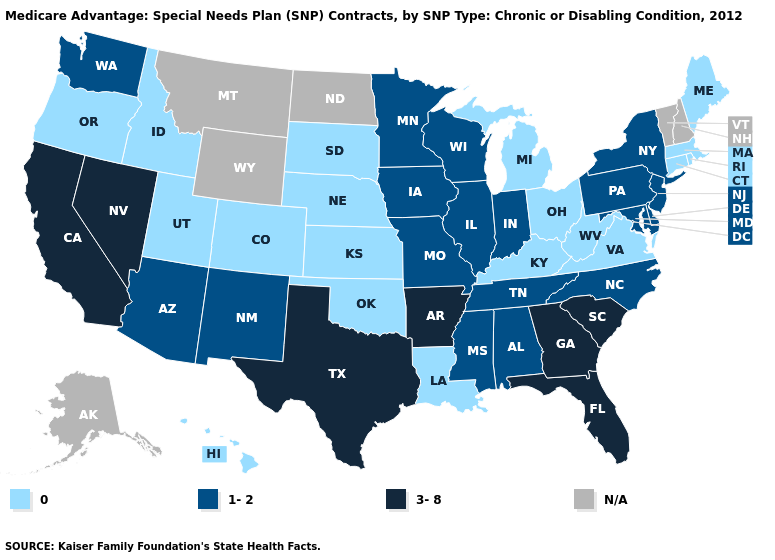Name the states that have a value in the range N/A?
Write a very short answer. Alaska, Montana, North Dakota, New Hampshire, Vermont, Wyoming. Name the states that have a value in the range 3-8?
Answer briefly. Arkansas, California, Florida, Georgia, Nevada, South Carolina, Texas. What is the value of Oregon?
Give a very brief answer. 0. Among the states that border Minnesota , which have the highest value?
Quick response, please. Iowa, Wisconsin. Among the states that border California , which have the lowest value?
Keep it brief. Oregon. Name the states that have a value in the range 1-2?
Write a very short answer. Alabama, Arizona, Delaware, Iowa, Illinois, Indiana, Maryland, Minnesota, Missouri, Mississippi, North Carolina, New Jersey, New Mexico, New York, Pennsylvania, Tennessee, Washington, Wisconsin. Does Oregon have the lowest value in the West?
Keep it brief. Yes. Name the states that have a value in the range 0?
Short answer required. Colorado, Connecticut, Hawaii, Idaho, Kansas, Kentucky, Louisiana, Massachusetts, Maine, Michigan, Nebraska, Ohio, Oklahoma, Oregon, Rhode Island, South Dakota, Utah, Virginia, West Virginia. How many symbols are there in the legend?
Concise answer only. 4. Name the states that have a value in the range 0?
Write a very short answer. Colorado, Connecticut, Hawaii, Idaho, Kansas, Kentucky, Louisiana, Massachusetts, Maine, Michigan, Nebraska, Ohio, Oklahoma, Oregon, Rhode Island, South Dakota, Utah, Virginia, West Virginia. Name the states that have a value in the range 3-8?
Short answer required. Arkansas, California, Florida, Georgia, Nevada, South Carolina, Texas. Which states have the lowest value in the South?
Concise answer only. Kentucky, Louisiana, Oklahoma, Virginia, West Virginia. Name the states that have a value in the range 3-8?
Quick response, please. Arkansas, California, Florida, Georgia, Nevada, South Carolina, Texas. 